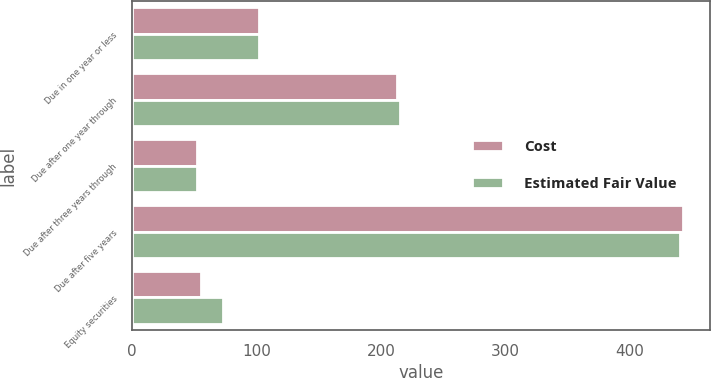<chart> <loc_0><loc_0><loc_500><loc_500><stacked_bar_chart><ecel><fcel>Due in one year or less<fcel>Due after one year through<fcel>Due after three years through<fcel>Due after five years<fcel>Equity securities<nl><fcel>Cost<fcel>102<fcel>213<fcel>52<fcel>443<fcel>55<nl><fcel>Estimated Fair Value<fcel>102<fcel>215<fcel>52<fcel>441<fcel>73<nl></chart> 